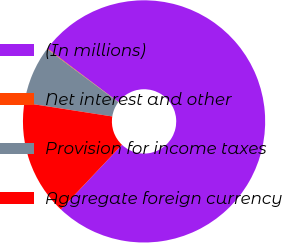<chart> <loc_0><loc_0><loc_500><loc_500><pie_chart><fcel>(In millions)<fcel>Net interest and other<fcel>Provision for income taxes<fcel>Aggregate foreign currency<nl><fcel>76.76%<fcel>0.08%<fcel>7.75%<fcel>15.41%<nl></chart> 